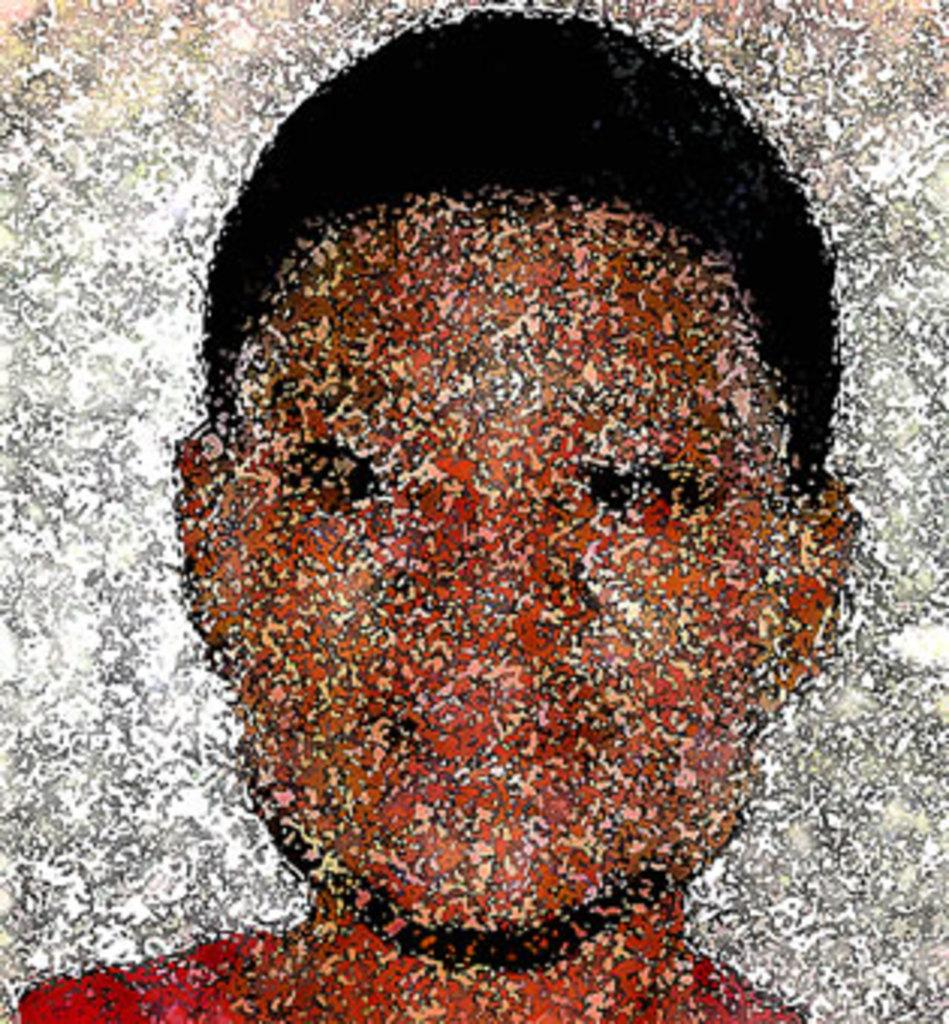What is the main subject of the image? The main subject of the image is a photograph. What is depicted in the photograph? The photograph is of a person. What color are the borders of the photograph? The borders of the photograph are white in color. How many sisters are depicted in the photograph in the image? There is no mention of sisters in the image; the photograph is of a single person. What type of tent is visible in the background of the photograph? There is no tent present in the image; the photograph is of a person, and no background is visible. 